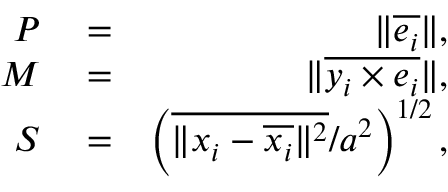Convert formula to latex. <formula><loc_0><loc_0><loc_500><loc_500>\begin{array} { r l r } { P } & = } & { \| \overline { { e _ { i } } } \| , } \\ { M } & = } & { \| \overline { { y _ { i } \times e _ { i } } } \| , } \\ { S } & = } & { \left ( \overline { { \| x _ { i } - \overline { { x _ { i } } } \| ^ { 2 } } } / a ^ { 2 } \right ) ^ { 1 / 2 } , } \end{array}</formula> 